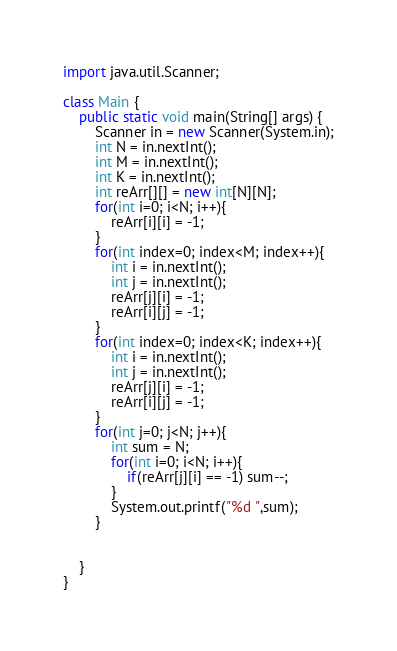Convert code to text. <code><loc_0><loc_0><loc_500><loc_500><_Java_>import java.util.Scanner;

class Main {
    public static void main(String[] args) {
        Scanner in = new Scanner(System.in);
        int N = in.nextInt();
        int M = in.nextInt();
        int K = in.nextInt();
        int reArr[][] = new int[N][N];
        for(int i=0; i<N; i++){
            reArr[i][i] = -1;
        }
        for(int index=0; index<M; index++){
            int i = in.nextInt();
            int j = in.nextInt();
            reArr[j][i] = -1;
            reArr[i][j] = -1;
        }
        for(int index=0; index<K; index++){
            int i = in.nextInt();
            int j = in.nextInt();
            reArr[j][i] = -1;
            reArr[i][j] = -1;
        }
        for(int j=0; j<N; j++){
            int sum = N;
            for(int i=0; i<N; i++){
                if(reArr[j][i] == -1) sum--;
            }
            System.out.printf("%d ",sum);
        }

        
    }
}</code> 